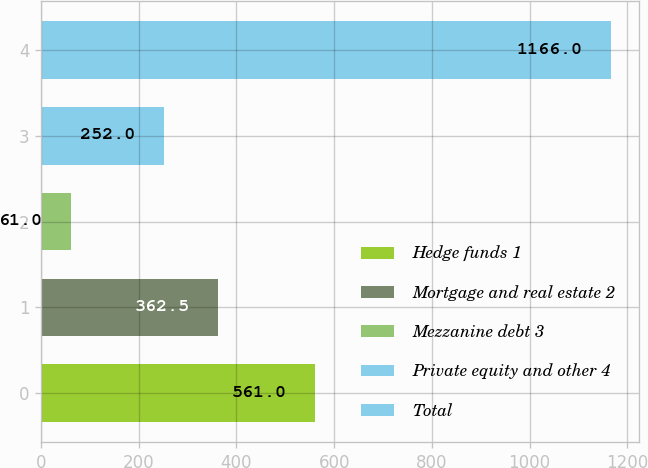Convert chart to OTSL. <chart><loc_0><loc_0><loc_500><loc_500><bar_chart><fcel>Hedge funds 1<fcel>Mortgage and real estate 2<fcel>Mezzanine debt 3<fcel>Private equity and other 4<fcel>Total<nl><fcel>561<fcel>362.5<fcel>61<fcel>252<fcel>1166<nl></chart> 